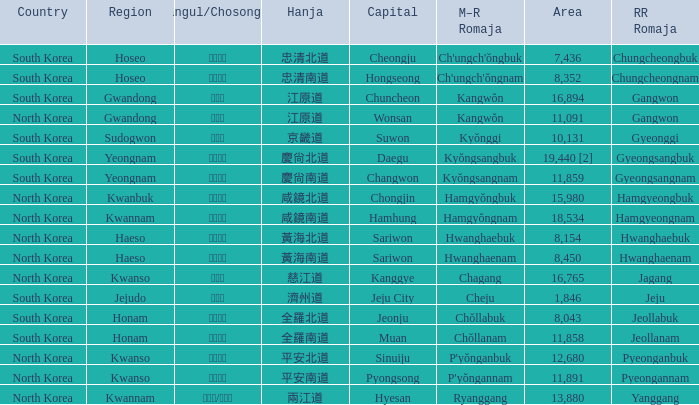Which capital has a Hangul of 경상남도? Changwon. 